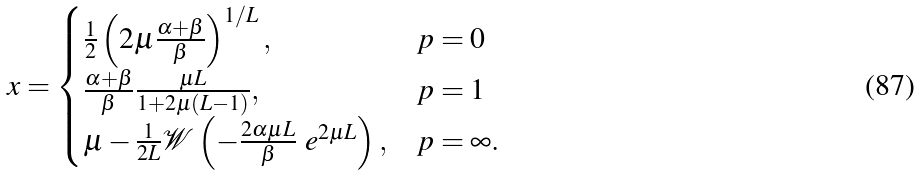Convert formula to latex. <formula><loc_0><loc_0><loc_500><loc_500>x = \begin{cases} \frac { 1 } { 2 } \left ( 2 \mu \frac { \alpha + \beta } { \beta } \right ) ^ { 1 / L } , & p = 0 \\ \frac { \alpha + \beta } { \beta } \frac { \mu L } { 1 + 2 \mu ( L - 1 ) } , & p = 1 \\ \mu - \frac { 1 } { 2 L } \mathcal { W } \left ( - \frac { 2 \alpha \mu L } { \beta } \ e ^ { 2 \mu L } \right ) , & p = \infty . \end{cases}</formula> 